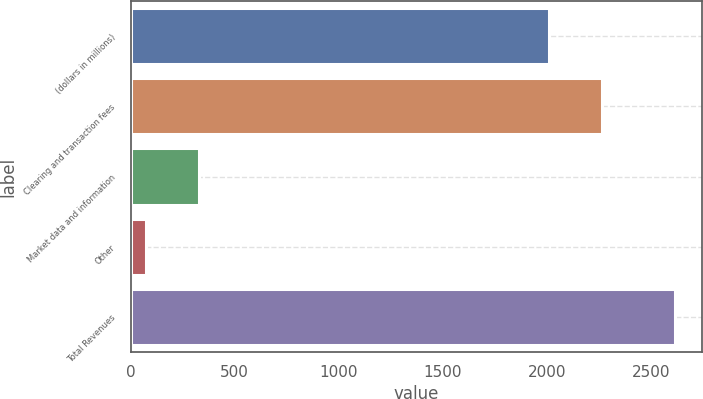Convert chart to OTSL. <chart><loc_0><loc_0><loc_500><loc_500><bar_chart><fcel>(dollars in millions)<fcel>Clearing and transaction fees<fcel>Market data and information<fcel>Other<fcel>Total Revenues<nl><fcel>2009<fcel>2262.86<fcel>331.1<fcel>74.2<fcel>2612.8<nl></chart> 